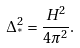Convert formula to latex. <formula><loc_0><loc_0><loc_500><loc_500>\Delta ^ { 2 } _ { ^ { * } } = \frac { H ^ { 2 } } { 4 \pi ^ { 2 } } .</formula> 